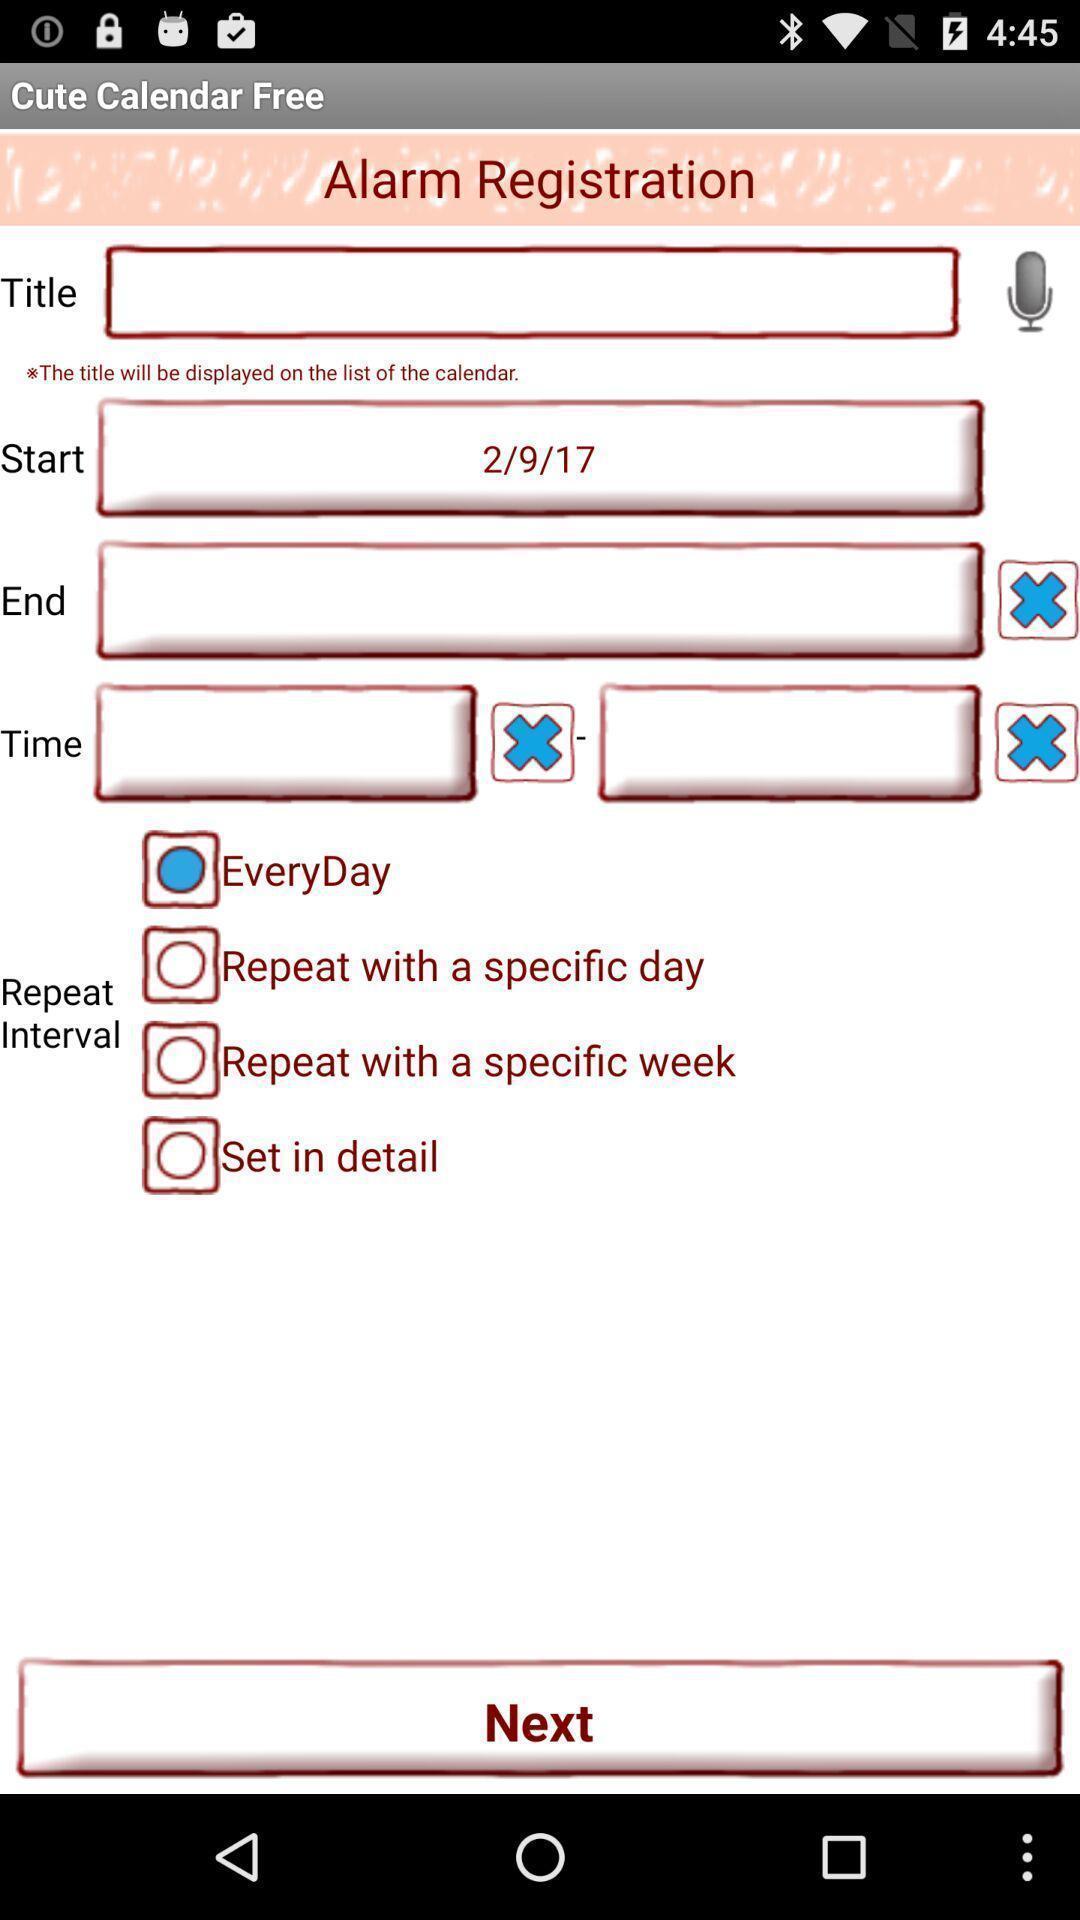Provide a detailed account of this screenshot. Registration page. 